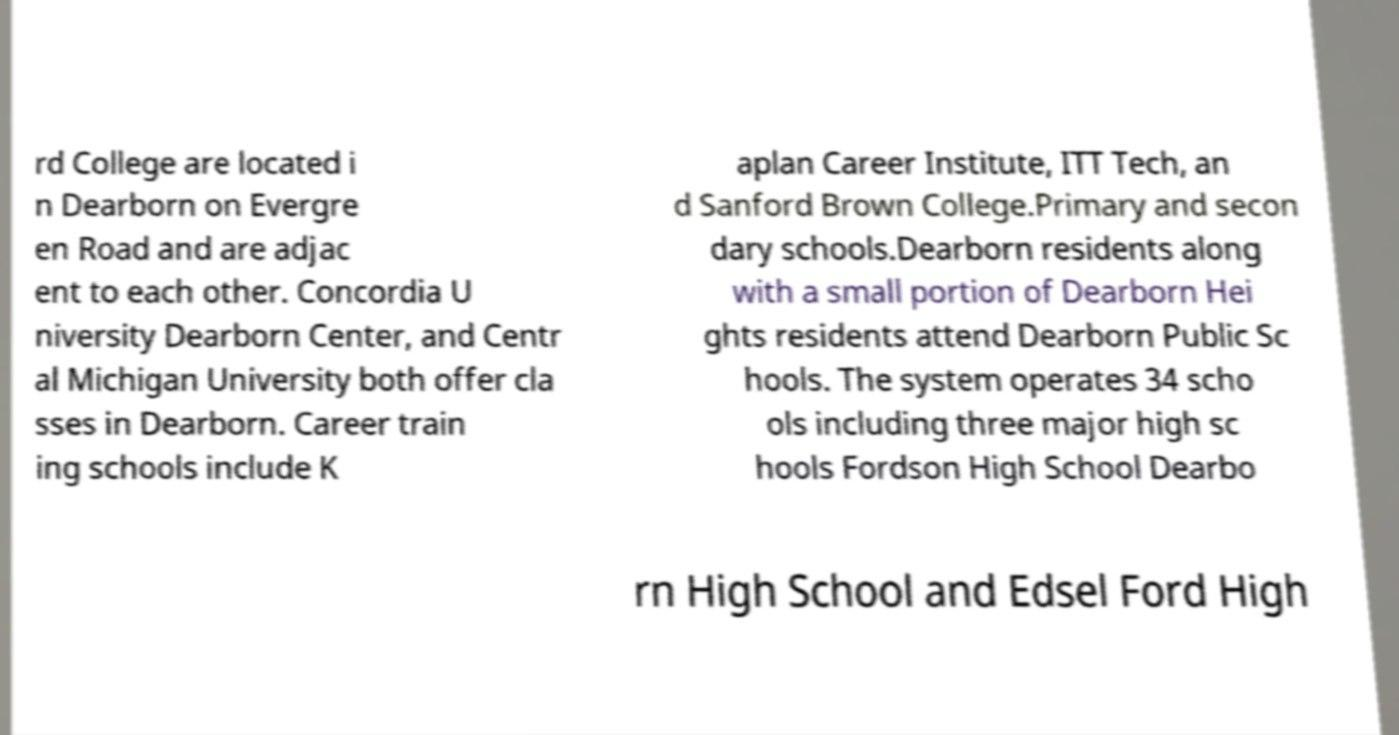Can you accurately transcribe the text from the provided image for me? rd College are located i n Dearborn on Evergre en Road and are adjac ent to each other. Concordia U niversity Dearborn Center, and Centr al Michigan University both offer cla sses in Dearborn. Career train ing schools include K aplan Career Institute, ITT Tech, an d Sanford Brown College.Primary and secon dary schools.Dearborn residents along with a small portion of Dearborn Hei ghts residents attend Dearborn Public Sc hools. The system operates 34 scho ols including three major high sc hools Fordson High School Dearbo rn High School and Edsel Ford High 